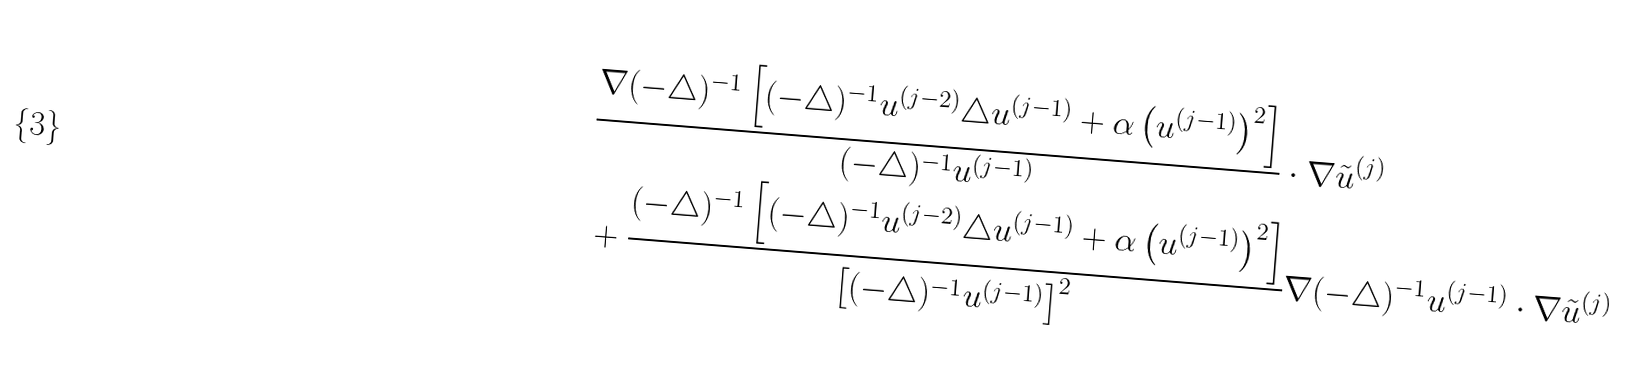Convert formula to latex. <formula><loc_0><loc_0><loc_500><loc_500>& \frac { \nabla ( - \triangle ) ^ { - 1 } \left [ ( - \triangle ) ^ { - 1 } u ^ { ( j - 2 ) } \triangle u ^ { ( j - 1 ) } + \alpha \left ( u ^ { ( j - 1 ) } \right ) ^ { 2 } \right ] } { ( - \triangle ) ^ { - 1 } u ^ { ( j - 1 ) } } \cdot \nabla \tilde { u } ^ { ( j ) } \\ & + \frac { ( - \triangle ) ^ { - 1 } \left [ ( - \triangle ) ^ { - 1 } u ^ { ( j - 2 ) } \triangle u ^ { ( j - 1 ) } + \alpha \left ( u ^ { ( j - 1 ) } \right ) ^ { 2 } \right ] } { \left [ ( - \triangle ) ^ { - 1 } u ^ { ( j - 1 ) } \right ] ^ { 2 } } \nabla ( - \triangle ) ^ { - 1 } u ^ { ( j - 1 ) } \cdot \nabla \tilde { u } ^ { ( j ) } \\</formula> 